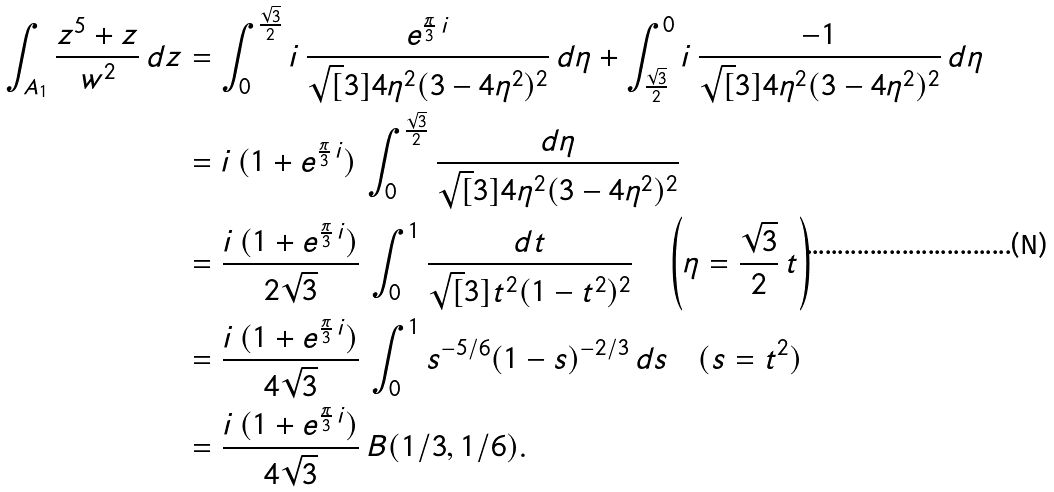Convert formula to latex. <formula><loc_0><loc_0><loc_500><loc_500>\int _ { A _ { 1 } } \frac { z ^ { 5 } + z } { w ^ { 2 } } \, d z & = \int ^ { \frac { \sqrt { 3 } } { 2 } } _ { 0 } i \, \frac { e ^ { \frac { \pi } { 3 } \, i } } { \sqrt { [ } 3 ] { 4 \eta ^ { 2 } ( 3 - 4 \eta ^ { 2 } ) ^ { 2 } } } \, d \eta + \int _ { \frac { \sqrt { 3 } } { 2 } } ^ { 0 } i \, \frac { - 1 } { \sqrt { [ } 3 ] { 4 \eta ^ { 2 } ( 3 - 4 \eta ^ { 2 } ) ^ { 2 } } } \, d \eta \\ & = i \, ( 1 + e ^ { \frac { \pi } { 3 } \, i } ) \, \int ^ { \frac { \sqrt { 3 } } { 2 } } _ { 0 } \frac { d \eta } { \sqrt { [ } 3 ] { 4 \eta ^ { 2 } ( 3 - 4 \eta ^ { 2 } ) ^ { 2 } } } \\ & = \frac { i \, ( 1 + e ^ { \frac { \pi } { 3 } \, i } ) } { 2 \sqrt { 3 } } \, \int _ { 0 } ^ { 1 } \frac { d t } { \sqrt { [ } 3 ] { t ^ { 2 } ( 1 - t ^ { 2 } ) ^ { 2 } } } \quad \left ( \eta = \frac { \sqrt { 3 } } { 2 } \, t \right ) \\ & = \frac { i \, ( 1 + e ^ { \frac { \pi } { 3 } \, i } ) } { 4 \sqrt { 3 } } \, \int ^ { 1 } _ { 0 } s ^ { - 5 / 6 } ( 1 - s ) ^ { - 2 / 3 } \, d s \quad ( s = t ^ { 2 } ) \\ & = \frac { i \, ( 1 + e ^ { \frac { \pi } { 3 } \, i } ) } { 4 \sqrt { 3 } } \, B ( 1 / 3 , 1 / 6 ) .</formula> 